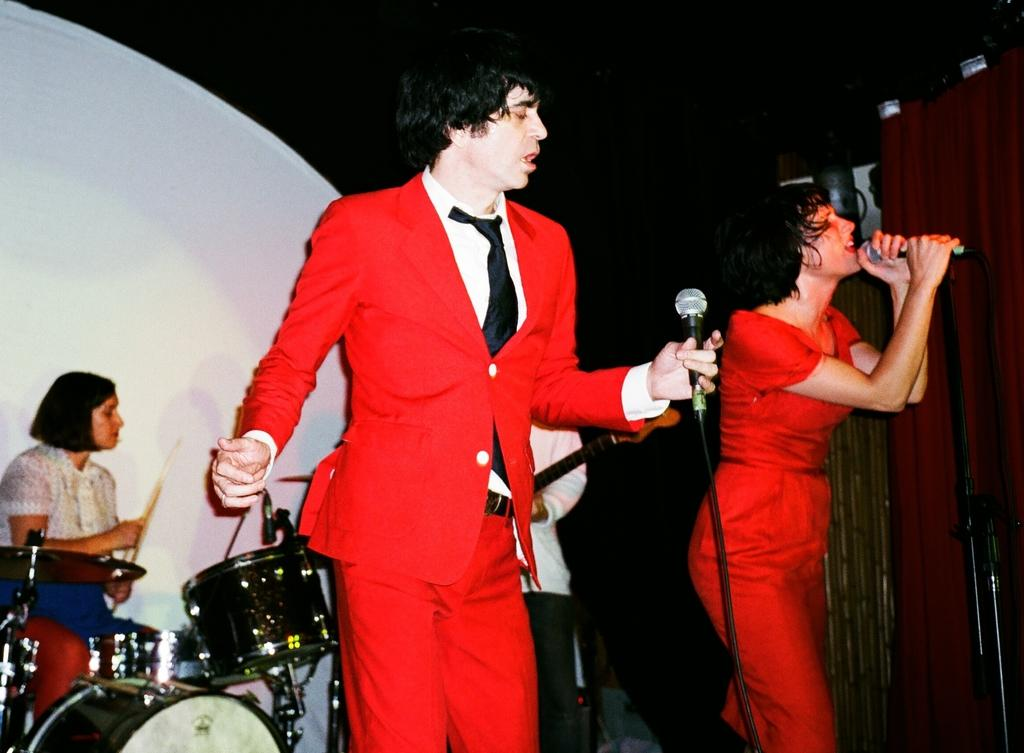How many people are in the image? There are four people in the image. What are the two people in the middle of the image doing? The two people in the middle of the image are holding microphones. What are the other two people in the image doing? The other two people in the image are playing musical instruments in the background. Are there any eggs visible in the image? No, there are no eggs present in the image. Is there a cobweb hanging from the microphones in the image? No, there is no cobweb visible in the image. 